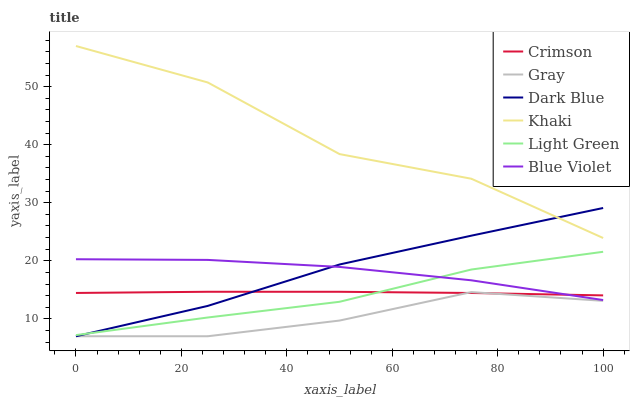Does Gray have the minimum area under the curve?
Answer yes or no. Yes. Does Khaki have the maximum area under the curve?
Answer yes or no. Yes. Does Dark Blue have the minimum area under the curve?
Answer yes or no. No. Does Dark Blue have the maximum area under the curve?
Answer yes or no. No. Is Crimson the smoothest?
Answer yes or no. Yes. Is Khaki the roughest?
Answer yes or no. Yes. Is Dark Blue the smoothest?
Answer yes or no. No. Is Dark Blue the roughest?
Answer yes or no. No. Does Gray have the lowest value?
Answer yes or no. Yes. Does Khaki have the lowest value?
Answer yes or no. No. Does Khaki have the highest value?
Answer yes or no. Yes. Does Dark Blue have the highest value?
Answer yes or no. No. Is Gray less than Khaki?
Answer yes or no. Yes. Is Khaki greater than Gray?
Answer yes or no. Yes. Does Gray intersect Crimson?
Answer yes or no. Yes. Is Gray less than Crimson?
Answer yes or no. No. Is Gray greater than Crimson?
Answer yes or no. No. Does Gray intersect Khaki?
Answer yes or no. No. 